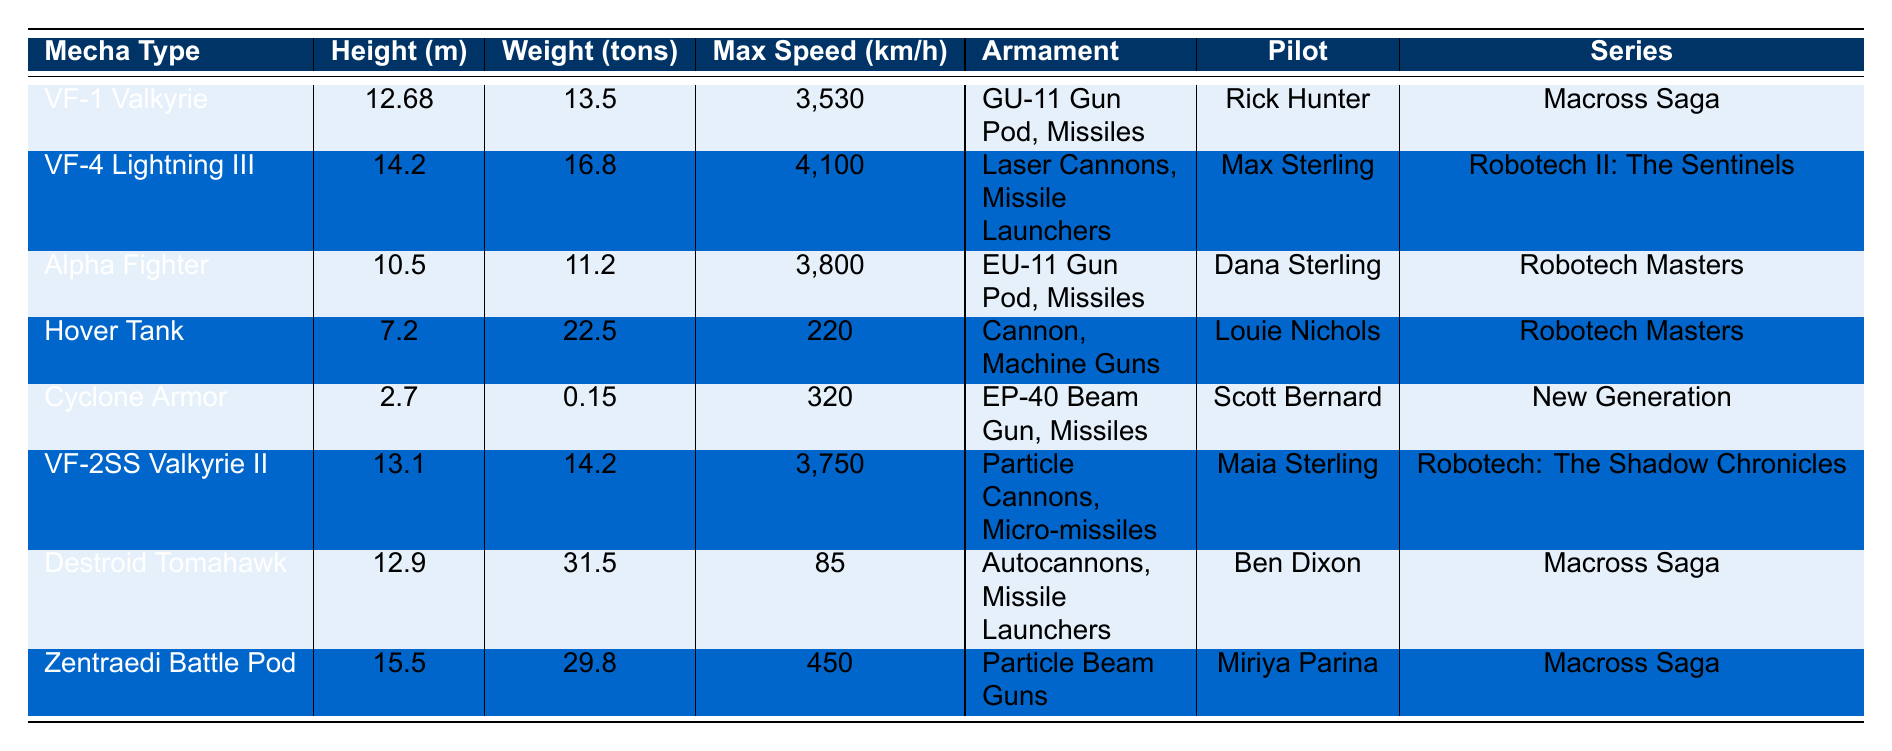What is the height of the VF-1 Valkyrie? The table lists the VF-1 Valkyrie, showing its height as 12.68 meters in the corresponding row.
Answer: 12.68 m Which mecha has the highest weight? By comparing the "Weight (tons)" column, the highest weight is 31.5 tons, associated with the Destroid Tomahawk.
Answer: Destroid Tomahawk How many mecha types are there in the table? The table has 8 rows of data, each representing a distinct mecha type listed under the "Mecha Type" column.
Answer: 8 Is the Alpha Fighter heavier than the Cyclone Armor? The Alpha Fighter weighs 11.2 tons, while the Cyclone Armor weighs only 0.15 tons, so the statement is true.
Answer: Yes What is the difference in max speed between the VF-4 Lightning III and the Hover Tank? The VF-4 Lightning III has a maximum speed of 4,100 km/h and the Hover Tank has 220 km/h. The difference is 4,100 - 220 = 3,880 km/h.
Answer: 3,880 km/h Which two mechas have the same series? Both the Destroid Tomahawk and VF-1 Valkyrie are from the "Macross Saga," indicated in the "Series" column.
Answer: Destroid Tomahawk and VF-1 Valkyrie What is the average height of the mecha types listed? The heights of the mecha types are 12.68, 14.2, 10.5, 7.2, 2.7, 13.1, 12.9, and 15.5 meters. Summing these gives 12.68 + 14.2 + 10.5 + 7.2 + 2.7 + 13.1 + 12.9 + 15.5 =  96.0 meters. Dividing by 8 gives an average height of 12.0 m.
Answer: 12.0 m Which pilot operates the highest-speed mecha? The highest max speed is 4,100 km/h for the VF-4 Lightning III, which is piloted by Max Sterling.
Answer: Max Sterling How many types of armaments are listed for the Cyclone Armor? The Cyclone Armor is equipped with an EP-40 Beam Gun and Missiles, totaling two types of armaments.
Answer: 2 types Are there any mechas from the New Generation series in the table? Yes, the Cyclone Armor is the only mecha listed from the New Generation series according to the "Series" column.
Answer: Yes If we compare the VF-1 Valkyrie and the Zenith Battle Pod, which has better speed-to-weight ratio? Calculating speed-to-weight ratios: VF-1 Valkyrie (3,530 km/h / 13.5 tons) is approximately 261.48 km/h per ton. For the Zentraedi Battle Pod (450 km/h / 29.8 tons), it’s about 15.08 km/h per ton. The VF-1 Valkyrie has a significantly better speed-to-weight ratio.
Answer: VF-1 Valkyrie 